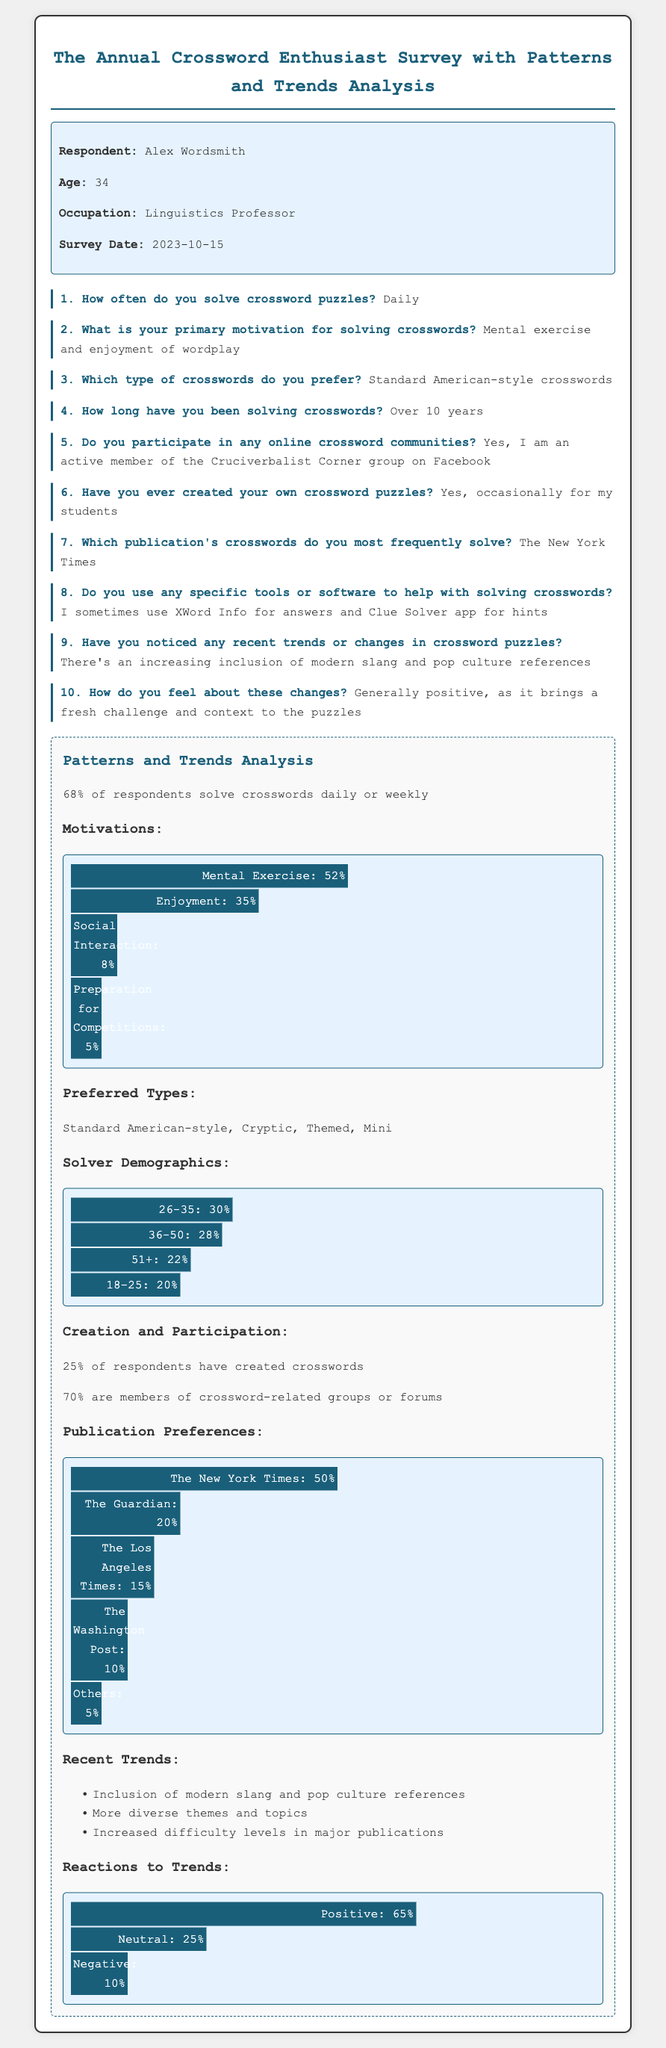How often does Alex solve crossword puzzles? The frequency with which Alex solves crossword puzzles is noted in question 1 of the survey.
Answer: Daily What is Alex's primary motivation for solving crosswords? The motivation is specified in question 2 of the survey.
Answer: Mental exercise and enjoyment of wordplay Which type of crossword does Alex prefer? The preferred crossword type is mentioned in question 3 of the survey.
Answer: Standard American-style crosswords How many years has Alex been solving crosswords? The duration of solving crosswords is detailed in question 4.
Answer: Over 10 years What percentage of respondents have created their own crossword puzzles? The percentage of respondents who have created crosswords is indicated in the "Creation and Participation" section.
Answer: 25% What is the most frequently solved publication by Alex? The publication mentioned by Alex is noted in question 7.
Answer: The New York Times What trend regarding crossword puzzles does Alex observe? The trend observed by Alex is found in question 9.
Answer: Increasing inclusion of modern slang and pop culture references How do most respondents feel about recent trends in crossword puzzles? The feelings of the respondents towards trends are located in the "Reactions to Trends" section.
Answer: Positive What chart shows the motivations for solving crosswords? The specific chart regarding motivations is found in the analysis section.
Answer: Motivations What percentage of respondents are members of crossword-related groups? The percentage of members in groups is stated in the "Creation and Participation" section.
Answer: 70% 